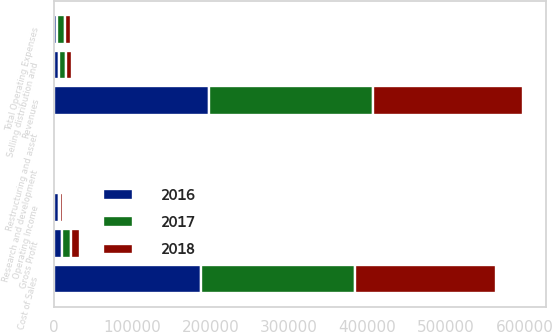Convert chart to OTSL. <chart><loc_0><loc_0><loc_500><loc_500><stacked_bar_chart><ecel><fcel>Revenues<fcel>Cost of Sales<fcel>Gross Profit<fcel>Selling distribution and<fcel>Research and development<fcel>Restructuring and asset<fcel>Total Operating Expenses<fcel>Operating Income<nl><fcel>2017<fcel>208357<fcel>197173<fcel>11184<fcel>8138<fcel>125<fcel>567<fcel>10422<fcel>762<nl><fcel>2016<fcel>198533<fcel>187262<fcel>11271<fcel>7460<fcel>341<fcel>18<fcel>4162<fcel>7109<nl><fcel>2018<fcel>190884<fcel>179468<fcel>11416<fcel>7379<fcel>392<fcel>203<fcel>7871<fcel>3545<nl></chart> 